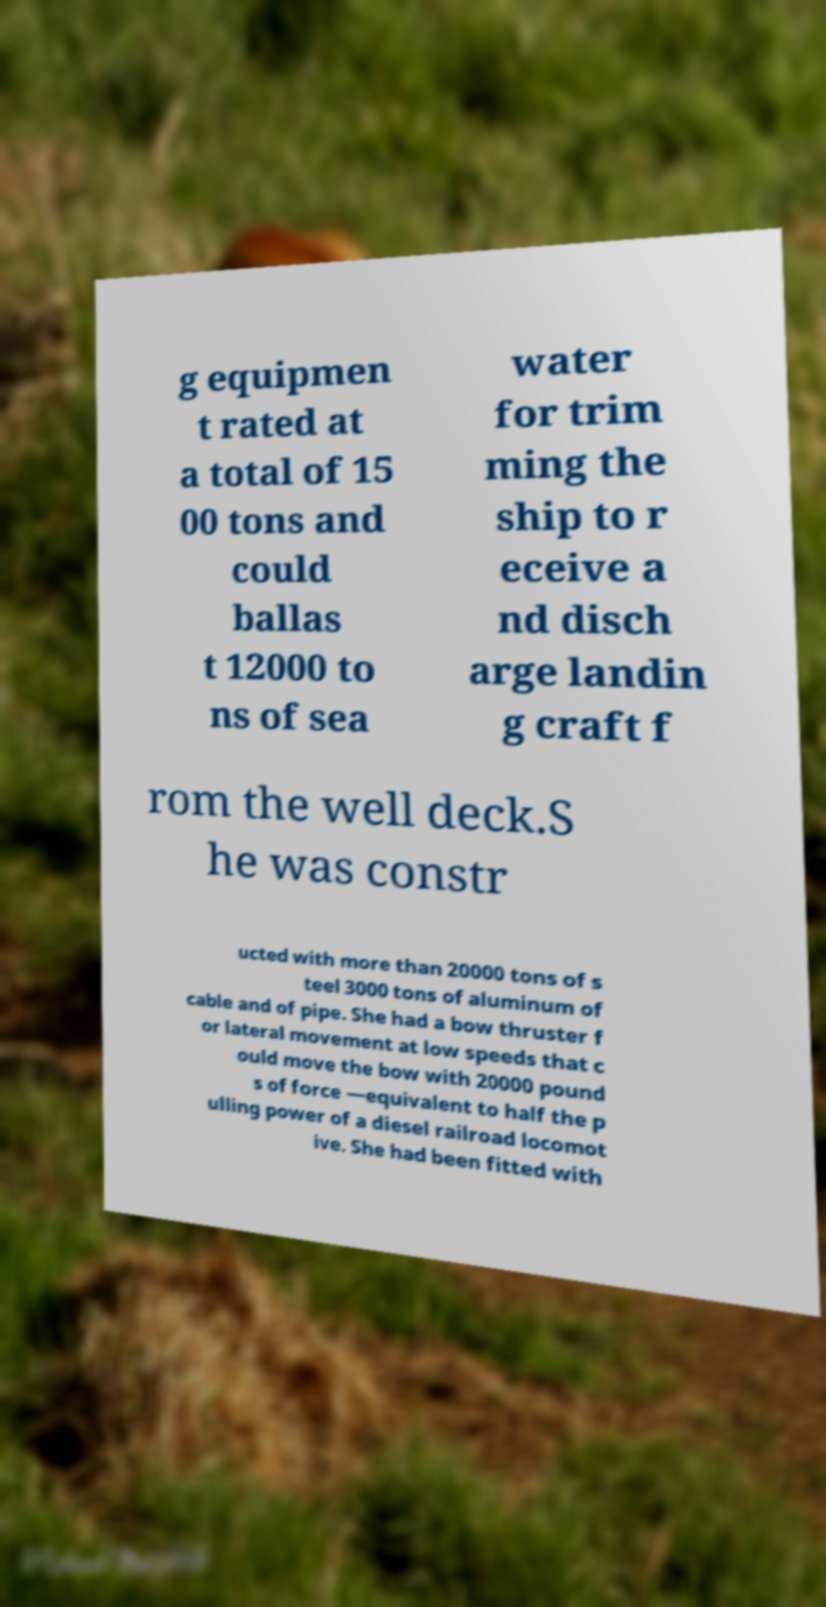For documentation purposes, I need the text within this image transcribed. Could you provide that? g equipmen t rated at a total of 15 00 tons and could ballas t 12000 to ns of sea water for trim ming the ship to r eceive a nd disch arge landin g craft f rom the well deck.S he was constr ucted with more than 20000 tons of s teel 3000 tons of aluminum of cable and of pipe. She had a bow thruster f or lateral movement at low speeds that c ould move the bow with 20000 pound s of force —equivalent to half the p ulling power of a diesel railroad locomot ive. She had been fitted with 